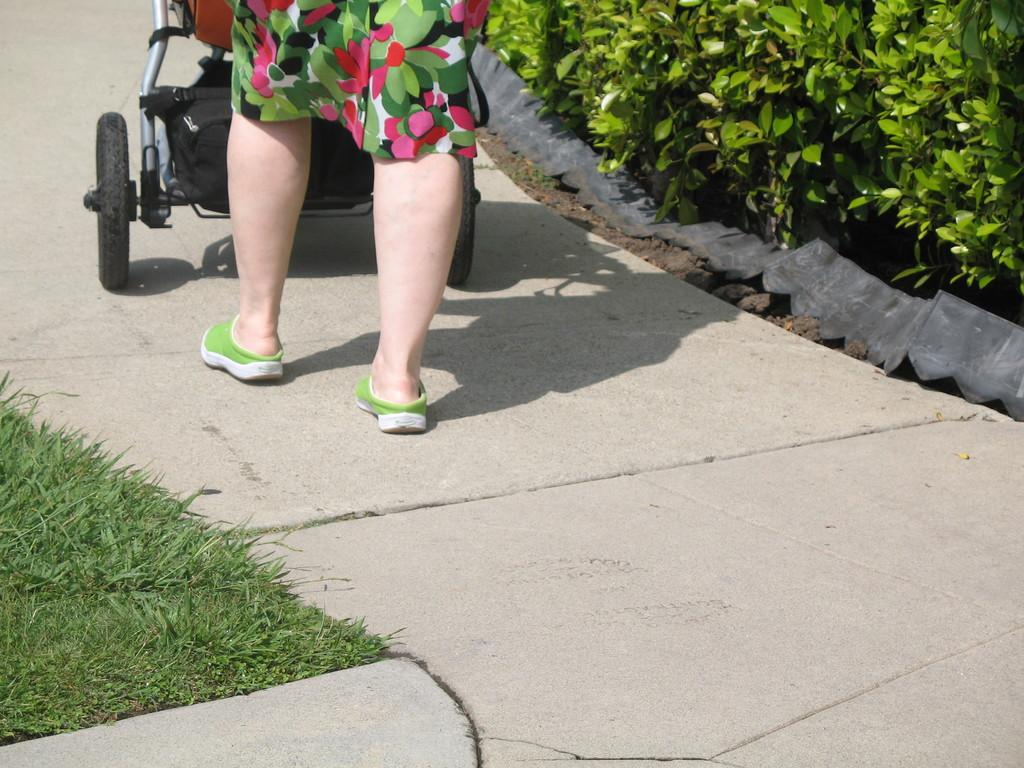What part of a person can be seen in the image? There are a person's legs in the image. What type of furniture is in the image? There is a baby chair in the image. What type of vegetation is present in the image? Grass is present in the image. What other type of plant can be seen in the image? Bushes are visible in the image. What type of bucket is being used to crush the pump in the image? There is no bucket or pump present in the image. 